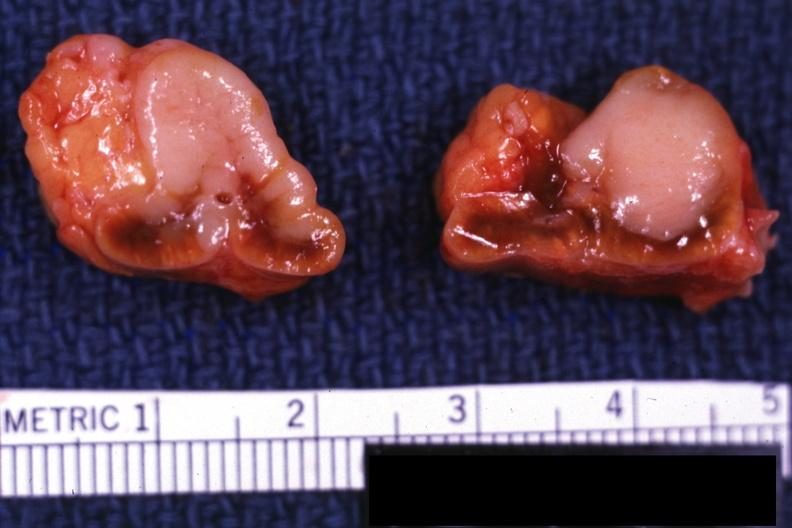what is present?
Answer the question using a single word or phrase. Metastatic carcinoma 